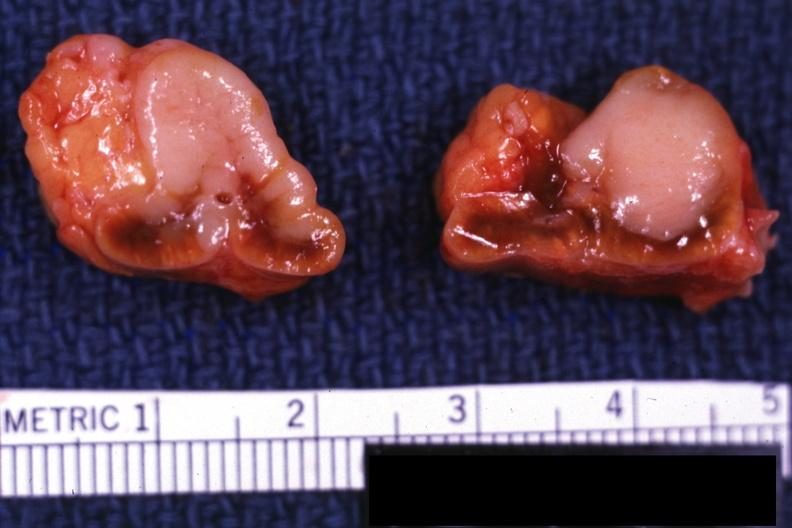what is present?
Answer the question using a single word or phrase. Metastatic carcinoma 